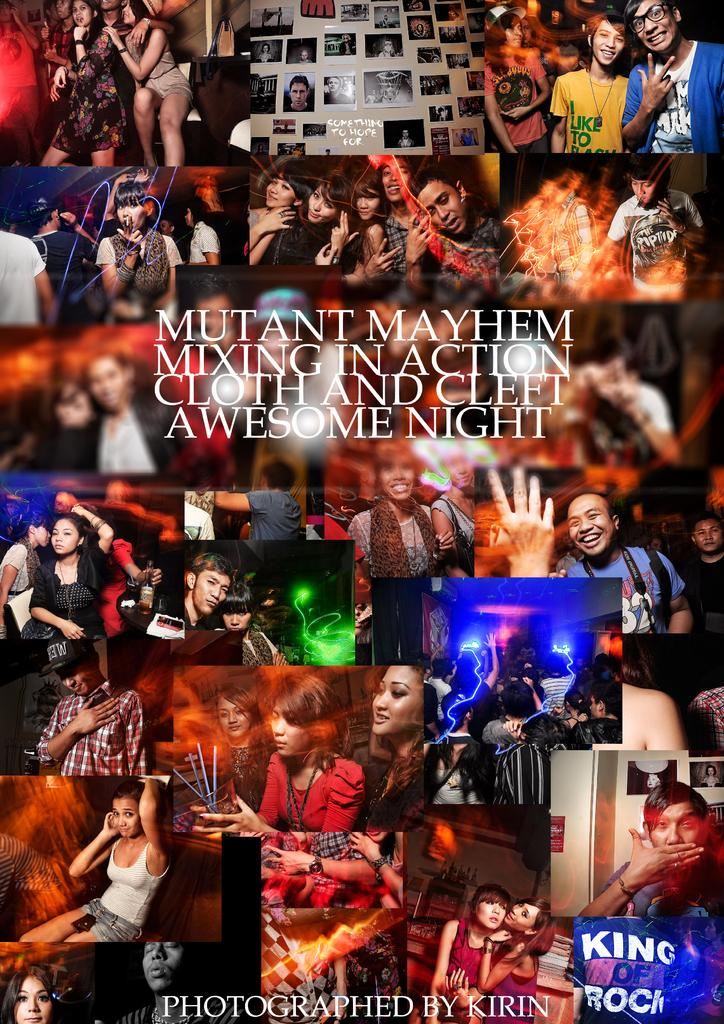What is the main subject of the image? The main subject of the image is a collage of photos. What can be seen in the photos? The photos depict different people. How are the people in the photos positioned? The people in the photos are sitting and standing in various styles. What type of ray can be seen swimming in the image? There is no ray present in the image; it contains a collage of photos depicting different people. How many potatoes are visible in the image? There are no potatoes present in the image; it contains a collage of photos depicting different people. 